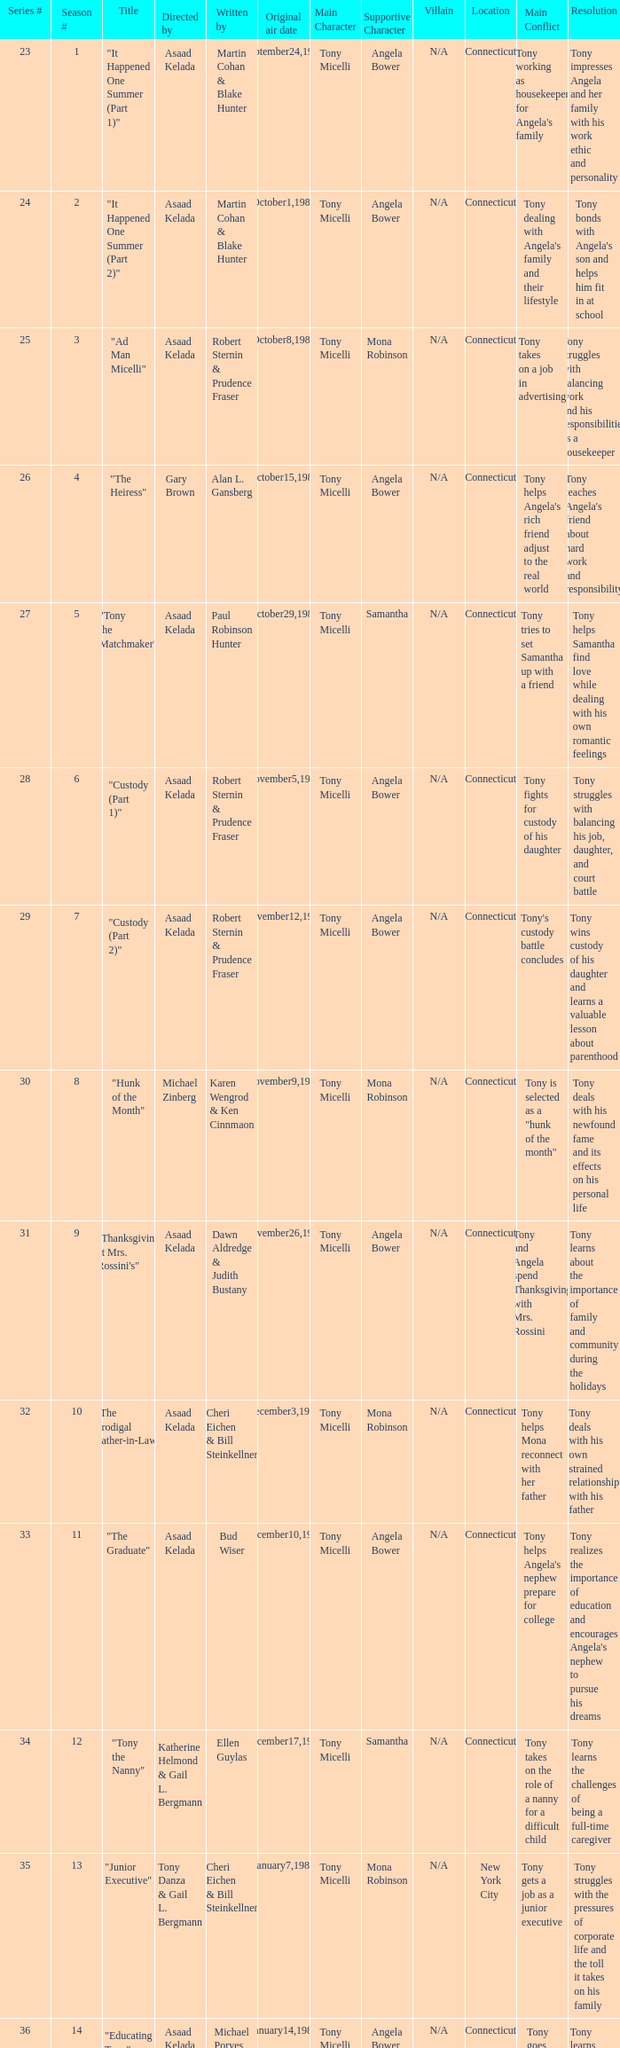What is the season where the episode "when worlds collide" was shown? 18.0. 